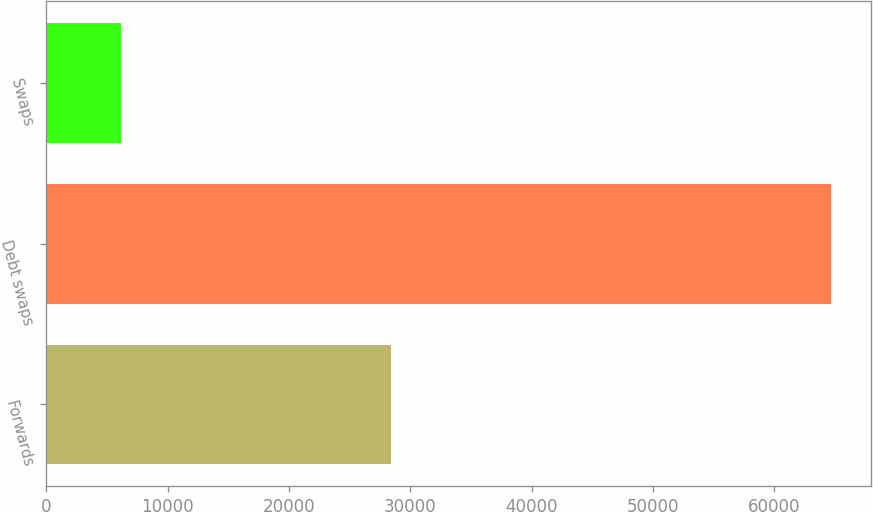<chart> <loc_0><loc_0><loc_500><loc_500><bar_chart><fcel>Forwards<fcel>Debt swaps<fcel>Swaps<nl><fcel>28411<fcel>64720<fcel>6165<nl></chart> 